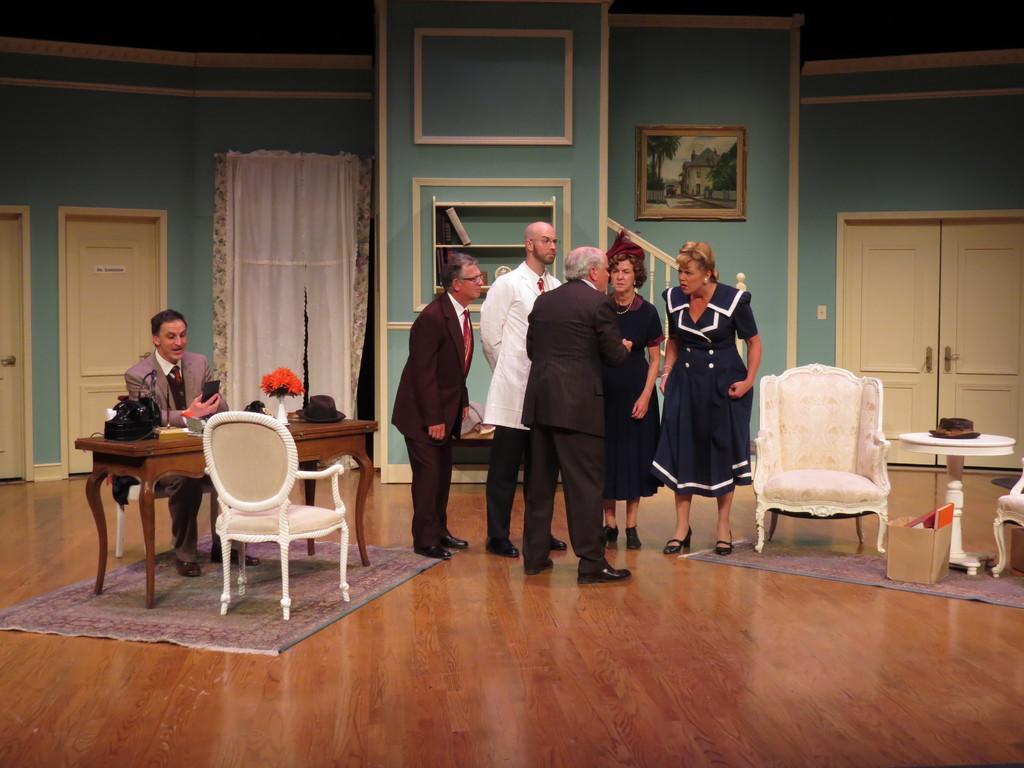Can you describe this image briefly? Here we can see a group of people standing and talking something into themselves and on the left side we can see a man sitting on a chair with table in front of him and there are couple of chairs present here and there and behind them we can see portrait and there are doors present and by seeing the whole picture we can say this is an act played by actors 